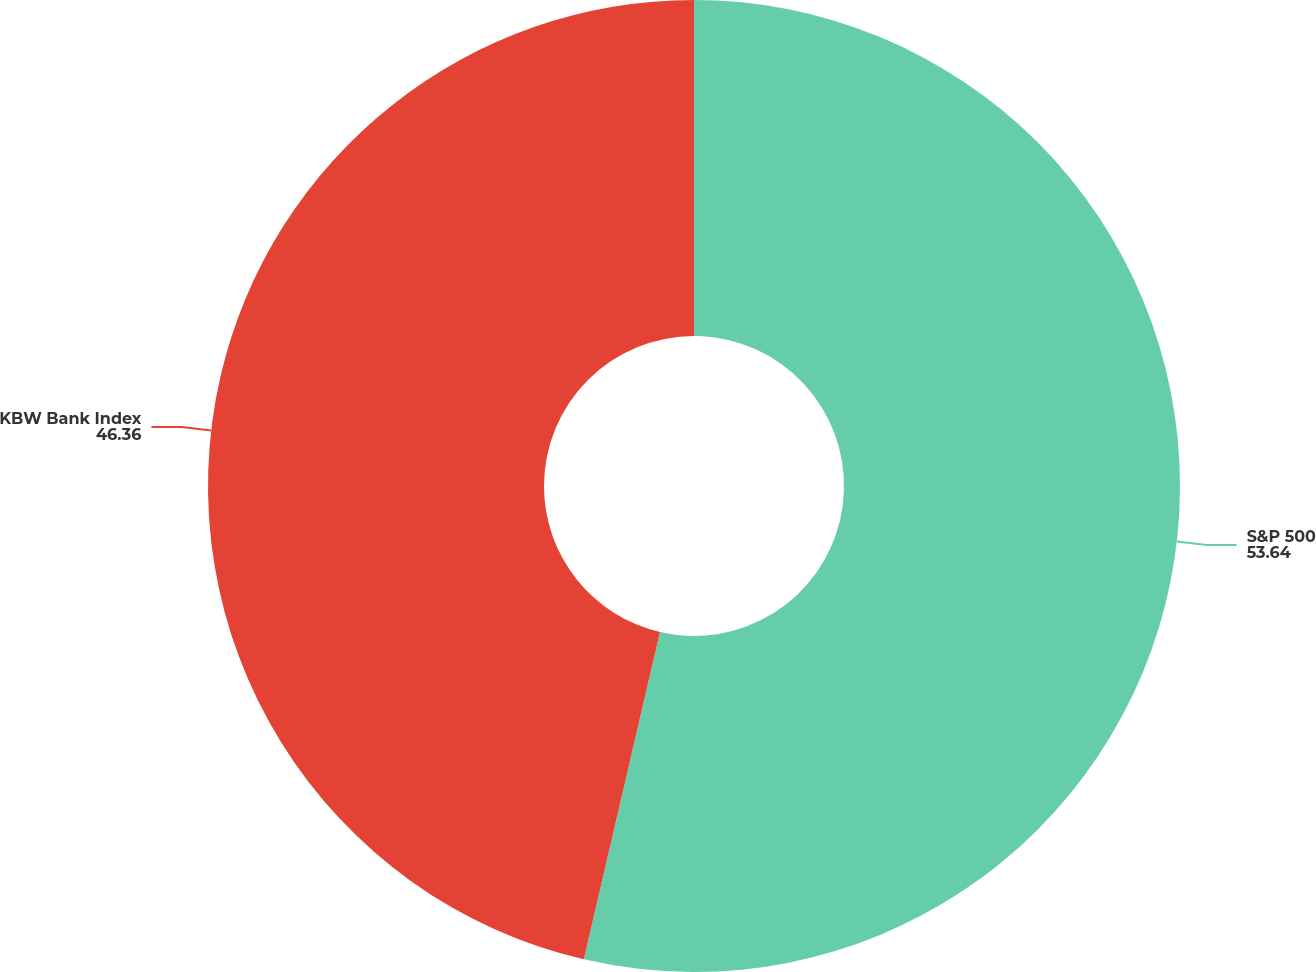Convert chart. <chart><loc_0><loc_0><loc_500><loc_500><pie_chart><fcel>S&P 500<fcel>KBW Bank Index<nl><fcel>53.64%<fcel>46.36%<nl></chart> 